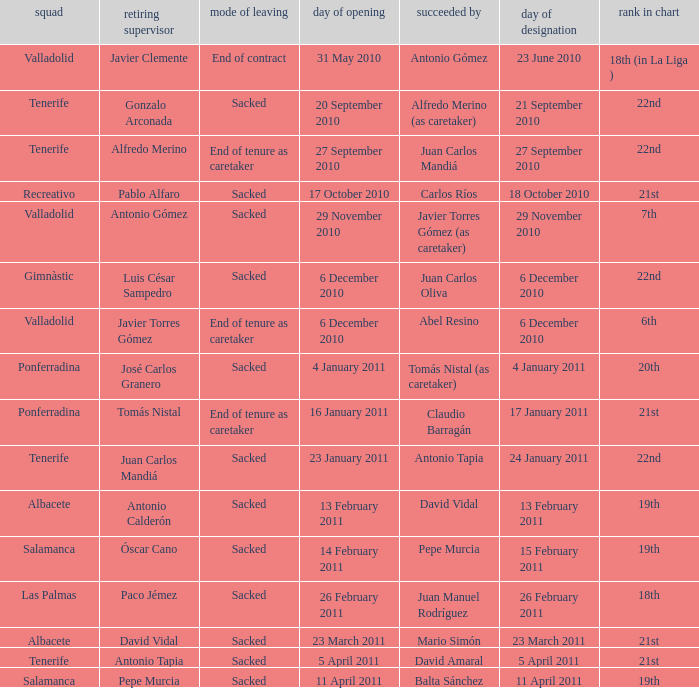What was the appointment date for outgoing manager luis césar sampedro 6 December 2010. 